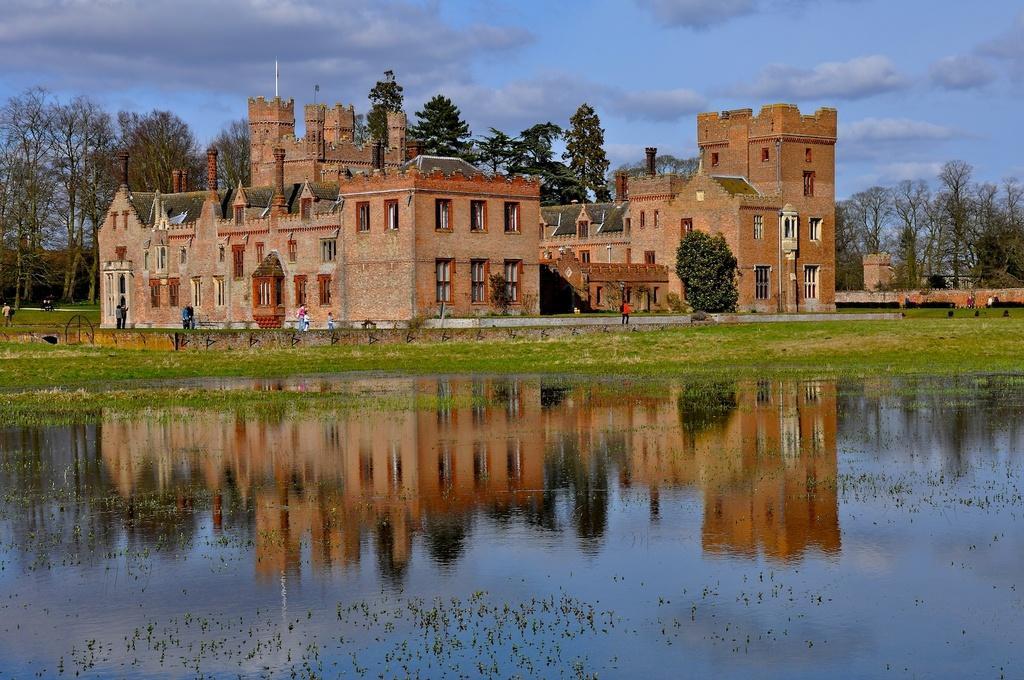Can you describe this image briefly? At the bottom of the image there is water. In the middle of the image few people are standing and walking. Behind them there are some buildings and trees. At the top of the image there are some clouds in the sky. 